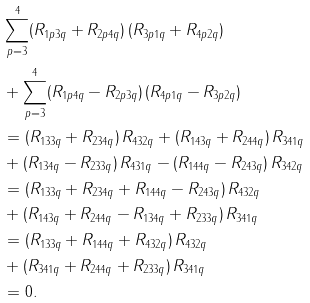Convert formula to latex. <formula><loc_0><loc_0><loc_500><loc_500>& \sum _ { p = 3 } ^ { 4 } ( R _ { 1 p 3 q } + R _ { 2 p 4 q } ) \, ( R _ { 3 p 1 q } + R _ { 4 p 2 q } ) \\ & + \sum _ { p = 3 } ^ { 4 } ( R _ { 1 p 4 q } - R _ { 2 p 3 q } ) \, ( R _ { 4 p 1 q } - R _ { 3 p 2 q } ) \\ & = ( R _ { 1 3 3 q } + R _ { 2 3 4 q } ) \, R _ { 4 3 2 q } + ( R _ { 1 4 3 q } + R _ { 2 4 4 q } ) \, R _ { 3 4 1 q } \\ & + ( R _ { 1 3 4 q } - R _ { 2 3 3 q } ) \, R _ { 4 3 1 q } - ( R _ { 1 4 4 q } - R _ { 2 4 3 q } ) \, R _ { 3 4 2 q } \\ & = ( R _ { 1 3 3 q } + R _ { 2 3 4 q } + R _ { 1 4 4 q } - R _ { 2 4 3 q } ) \, R _ { 4 3 2 q } \\ & + ( R _ { 1 4 3 q } + R _ { 2 4 4 q } - R _ { 1 3 4 q } + R _ { 2 3 3 q } ) \, R _ { 3 4 1 q } \\ & = ( R _ { 1 3 3 q } + R _ { 1 4 4 q } + R _ { 4 3 2 q } ) \, R _ { 4 3 2 q } \\ & + ( R _ { 3 4 1 q } + R _ { 2 4 4 q } + R _ { 2 3 3 q } ) \, R _ { 3 4 1 q } \\ & = 0 .</formula> 